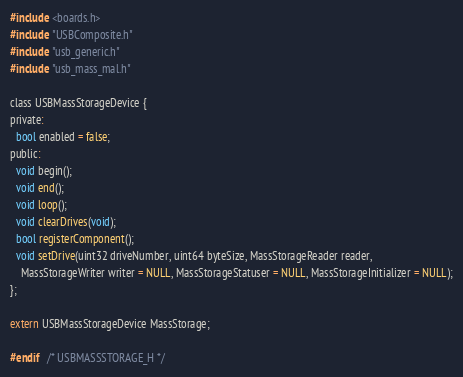Convert code to text. <code><loc_0><loc_0><loc_500><loc_500><_C_>
#include <boards.h>
#include "USBComposite.h"
#include "usb_generic.h"
#include "usb_mass_mal.h"

class USBMassStorageDevice {
private:
  bool enabled = false;
public:
  void begin();
  void end();
  void loop();
  void clearDrives(void);
  bool registerComponent();
  void setDrive(uint32 driveNumber, uint64 byteSize, MassStorageReader reader,
	MassStorageWriter writer = NULL, MassStorageStatuser = NULL, MassStorageInitializer = NULL);
};

extern USBMassStorageDevice MassStorage;

#endif	/* USBMASSSTORAGE_H */

</code> 